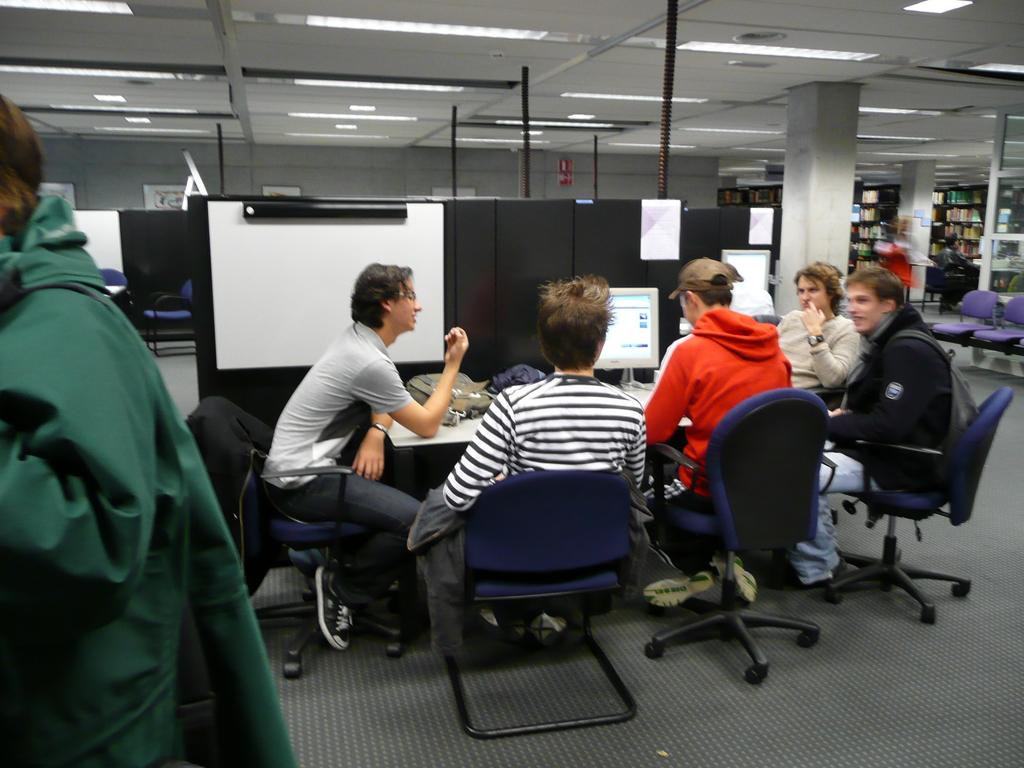What are the people in the image doing? The people in the image are sitting on chairs. What can be seen on the table in the image? There is a monitor on a table in the image. Can you describe the clothing of one of the people in the image? A man is wearing a green jacket in the image. What type of wool is being spun by the people in the image? There is no wool or spinning activity present in the image. 